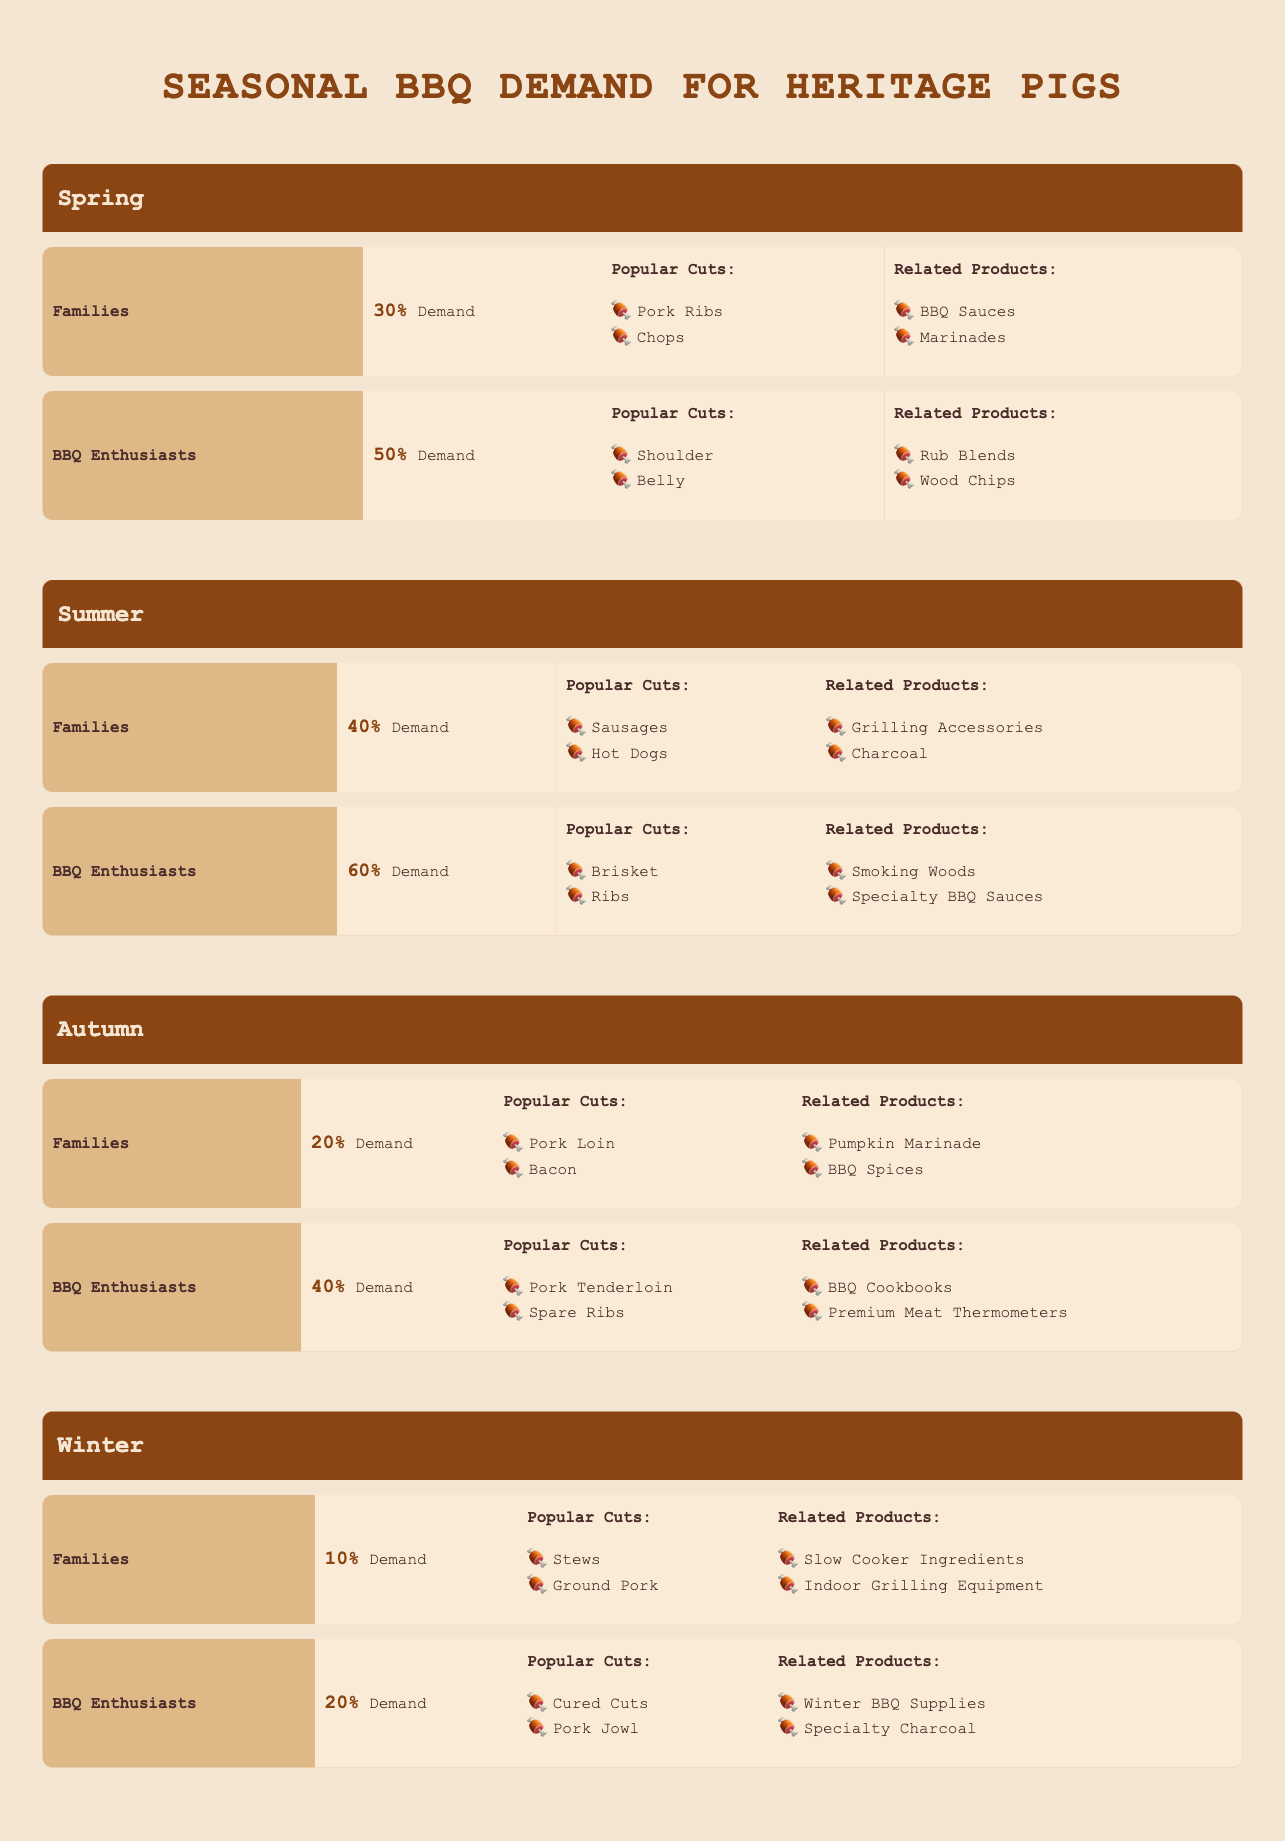What is the most popular cut among families in Spring? Families in Spring prefer Pork Ribs and Chops, but since the question asks for the most popular cut, it can be inferred that "Pork Ribs" is more commonly associated with BBQ among families.
Answer: Pork Ribs Which season has the highest demand percentage from BBQ enthusiasts? From the table, Summer has the highest demand percentage for BBQ enthusiasts at 60%.
Answer: Summer What are the related products for BBQ enthusiasts in Autumn? According to the table, BBQ enthusiasts in Autumn have BBQ Cookbooks and Premium Meat Thermometers as their related products.
Answer: BBQ Cookbooks and Premium Meat Thermometers What is the average demand percentage among families across all seasons? The demand percentages for families are 30% (Spring), 40% (Summer), 20% (Autumn), and 10% (Winter). Summing these gives 30 + 40 + 20 + 10 = 100. Dividing this by four seasons results in an average of 100/4 = 25%.
Answer: 25% Is the demand for related products among BBQ enthusiasts higher in Winter than in Spring? BBQ enthusiasts in Spring have Demand for Rub Blends and Wood Chips, while in Winter, they have Winter BBQ Supplies and Specialty Charcoal. Although the types of products differ, the demand percentages in Spring (50%) are higher than in Winter (20%). So, the statement is false.
Answer: No What are the popular cuts for families in Summer? The table shows that in Summer, families prefer Sausages and Hot Dogs as their popular cuts.
Answer: Sausages and Hot Dogs If you look at the data, did demand among BBQ enthusiasts decrease from Autumn to Winter? BBQ enthusiasts have a demand of 40% in Autumn and 20% in Winter, which indicates a decline. Therefore, yes, the demand did decrease from Autumn to Winter.
Answer: Yes What is the total demand percentage for families across all seasons? The demand percentages for families are 30% (Spring), 40% (Summer), 20% (Autumn), and 10% (Winter). The total demand is 30 + 40 + 20 + 10 = 100%.
Answer: 100% 